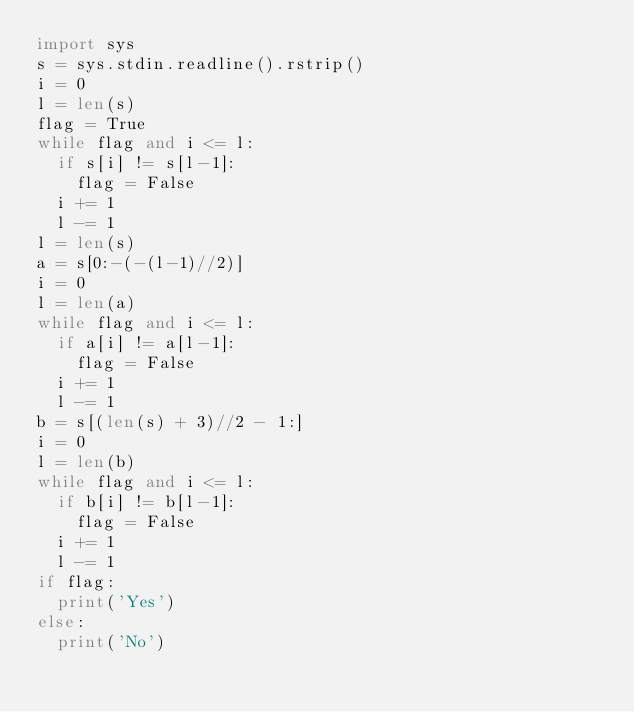<code> <loc_0><loc_0><loc_500><loc_500><_Python_>import sys
s = sys.stdin.readline().rstrip()
i = 0
l = len(s)
flag = True
while flag and i <= l:
  if s[i] != s[l-1]:
    flag = False
  i += 1
  l -= 1
l = len(s)
a = s[0:-(-(l-1)//2)]
i = 0
l = len(a)
while flag and i <= l:
  if a[i] != a[l-1]:
    flag = False
  i += 1
  l -= 1
b = s[(len(s) + 3)//2 - 1:]
i = 0
l = len(b)
while flag and i <= l:
  if b[i] != b[l-1]:
    flag = False
  i += 1
  l -= 1
if flag:
  print('Yes')
else:
  print('No')
</code> 